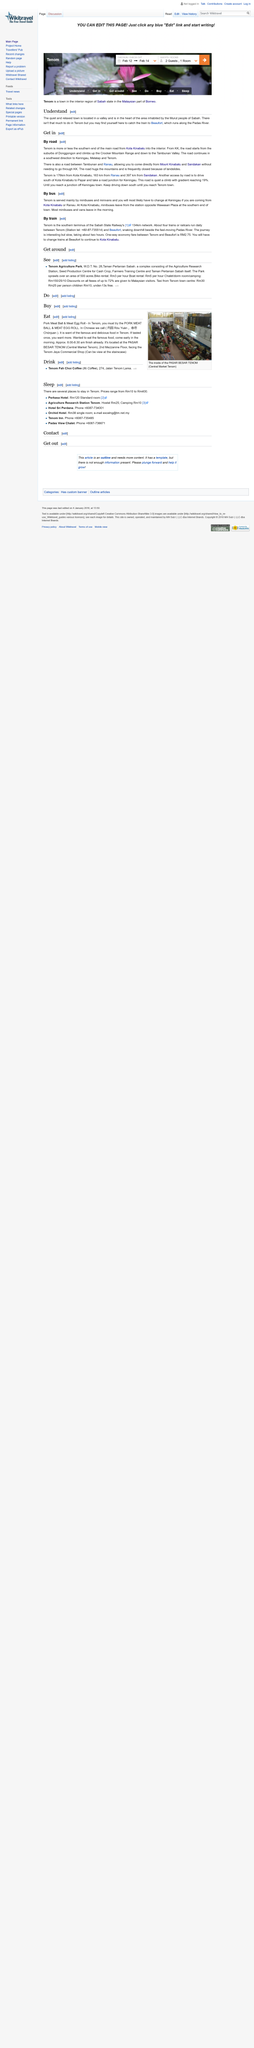Give some essential details in this illustration. The boat rental costs RM5 per hour, as stated. Tenom is a distance of 176 kilometers from Kota Kinabalu. Tenom is approximately 397 kilometers from Sandakan. It is recommended to eat the pork meat ball in the morning, preferably before 8:30 AM, as this is considered the best time to enjoy its delicious flavor and texture. Tenom Agriculture Park covers an area of 500 acres, according to "See". 